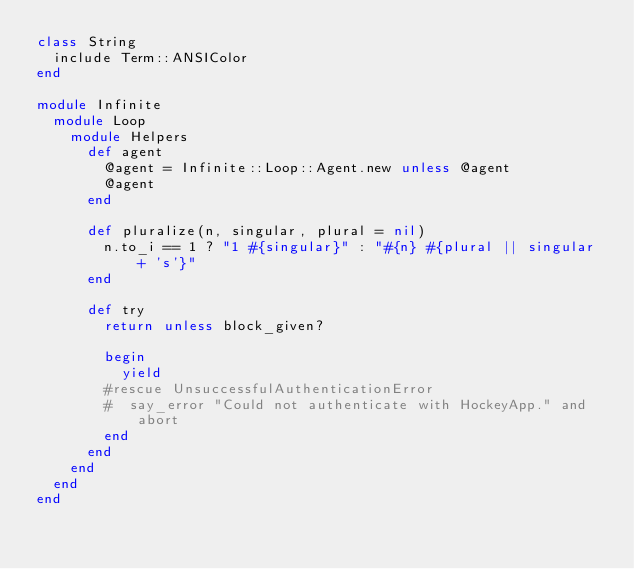Convert code to text. <code><loc_0><loc_0><loc_500><loc_500><_Ruby_>class String
  include Term::ANSIColor
end

module Infinite
  module Loop
    module Helpers
      def agent
        @agent = Infinite::Loop::Agent.new unless @agent
        @agent
      end
      
      def pluralize(n, singular, plural = nil)
        n.to_i == 1 ? "1 #{singular}" : "#{n} #{plural || singular + 's'}"
      end
      
      def try
        return unless block_given?

        begin
          yield
        #rescue UnsuccessfulAuthenticationError
        #  say_error "Could not authenticate with HockeyApp." and abort
        end
      end
    end
  end
end</code> 